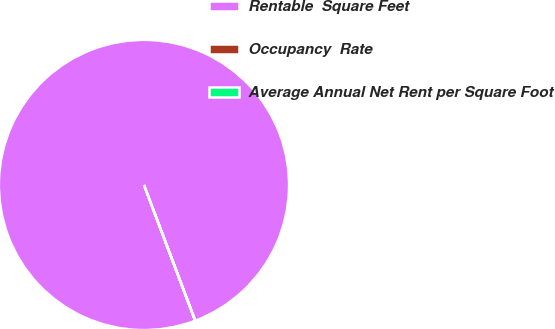<chart> <loc_0><loc_0><loc_500><loc_500><pie_chart><fcel>Rentable  Square Feet<fcel>Occupancy  Rate<fcel>Average Annual Net Rent per Square Foot<nl><fcel>100.0%<fcel>0.0%<fcel>0.0%<nl></chart> 